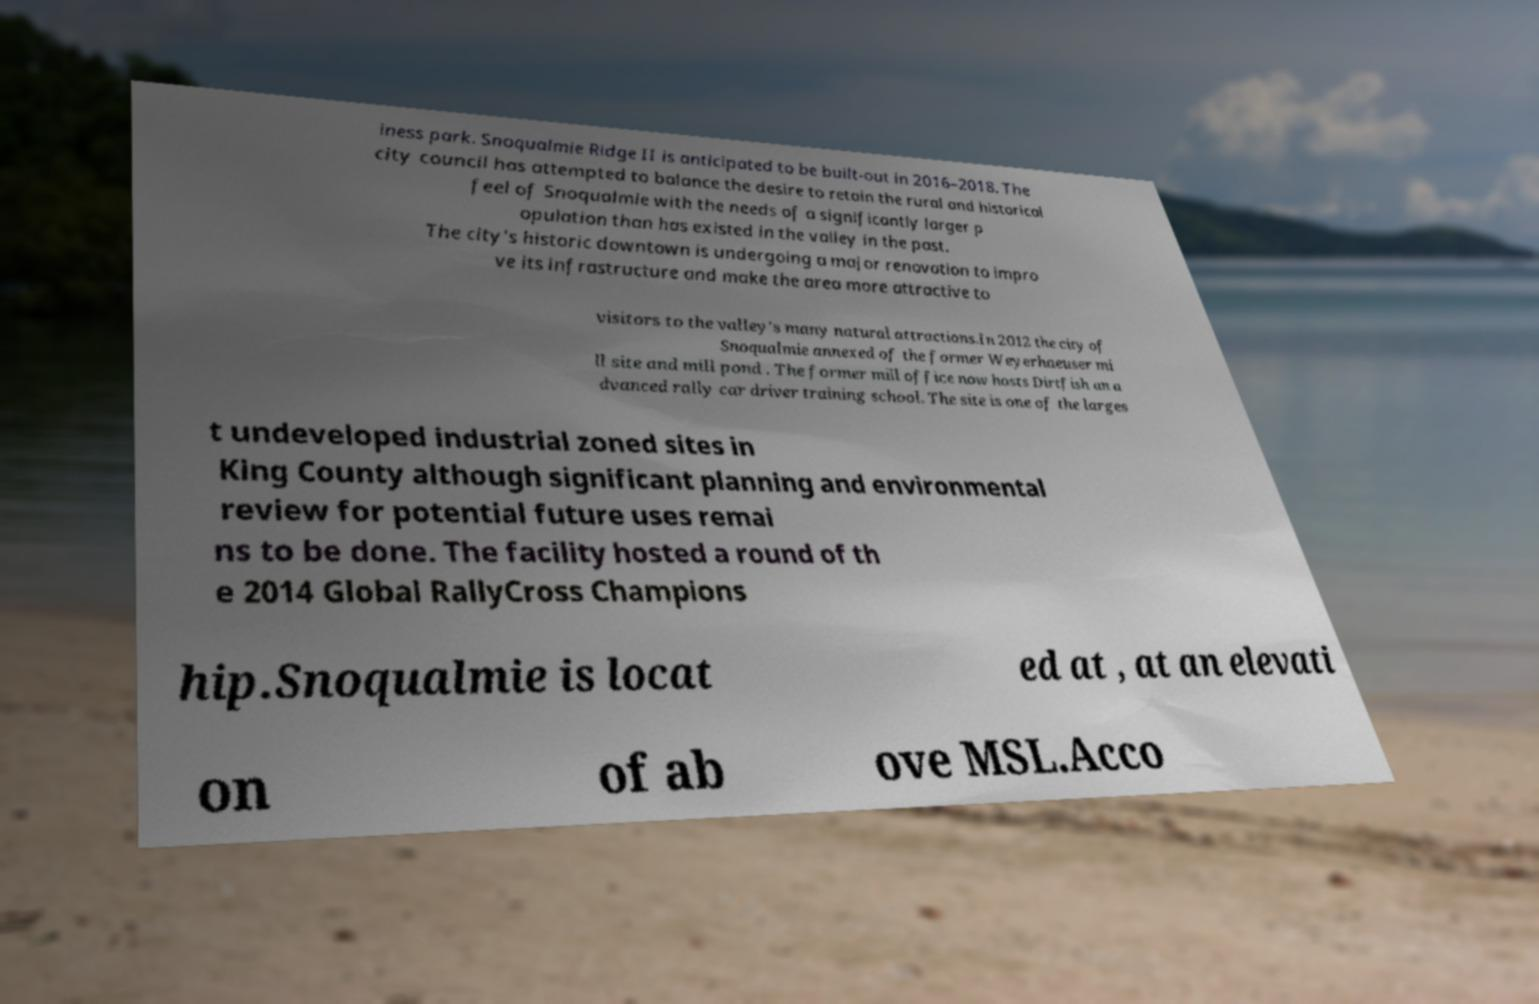I need the written content from this picture converted into text. Can you do that? iness park. Snoqualmie Ridge II is anticipated to be built-out in 2016–2018. The city council has attempted to balance the desire to retain the rural and historical feel of Snoqualmie with the needs of a significantly larger p opulation than has existed in the valley in the past. The city's historic downtown is undergoing a major renovation to impro ve its infrastructure and make the area more attractive to visitors to the valley's many natural attractions.In 2012 the city of Snoqualmie annexed of the former Weyerhaeuser mi ll site and mill pond . The former mill office now hosts Dirtfish an a dvanced rally car driver training school. The site is one of the larges t undeveloped industrial zoned sites in King County although significant planning and environmental review for potential future uses remai ns to be done. The facility hosted a round of th e 2014 Global RallyCross Champions hip.Snoqualmie is locat ed at , at an elevati on of ab ove MSL.Acco 